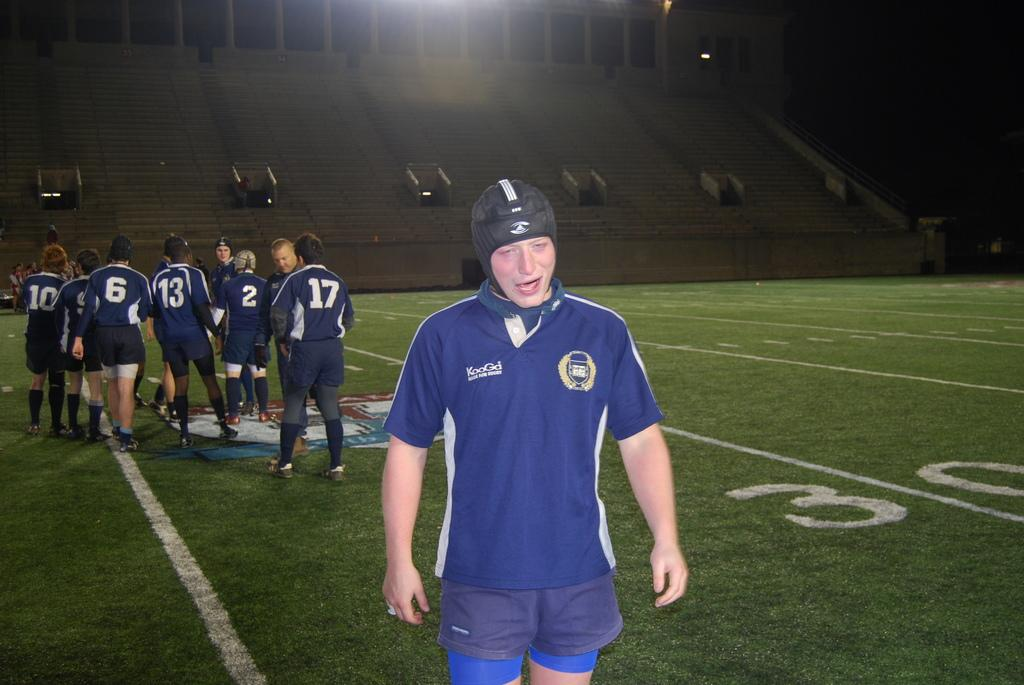Provide a one-sentence caption for the provided image. Players 10, 6, 13, 2, and 17 remained on the field. 